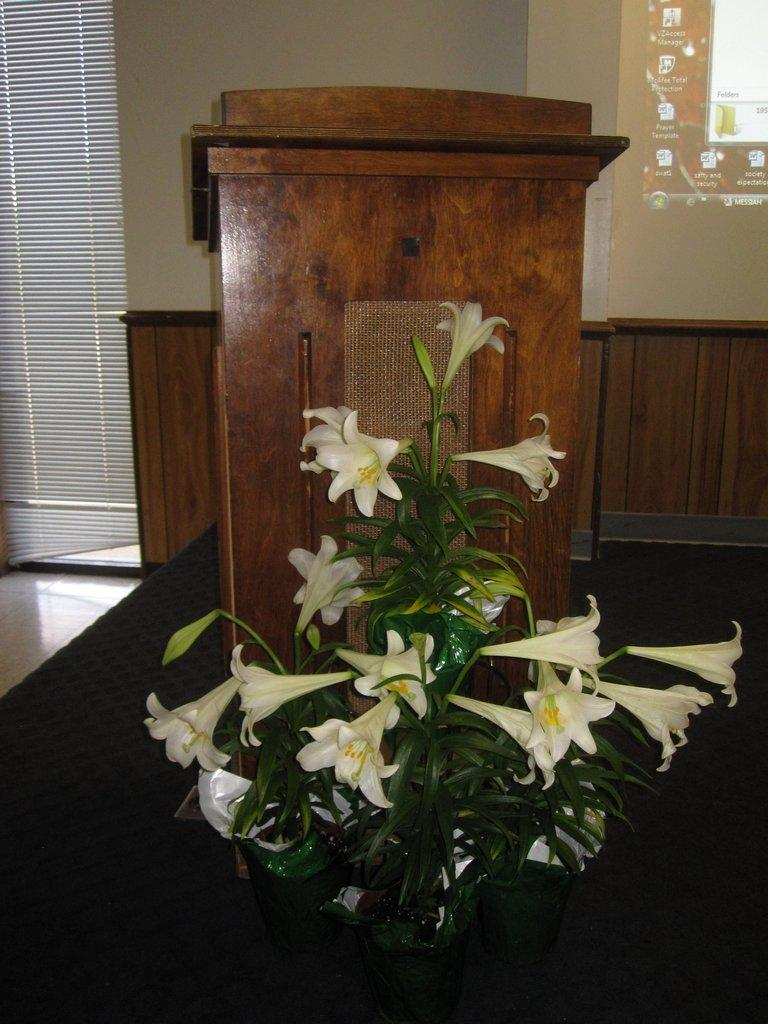What can be seen in the foreground of the image? There are flowers and a wooden desk in the foreground of the image. What might be visible in the background of the image? It appears there is a window and a screen in the background of the image. What type of nerve can be seen in the image? There is no nerve present in the image. How does the image make you feel? The image itself does not evoke a specific feeling, as it is a static representation of objects and does not have emotional content. 